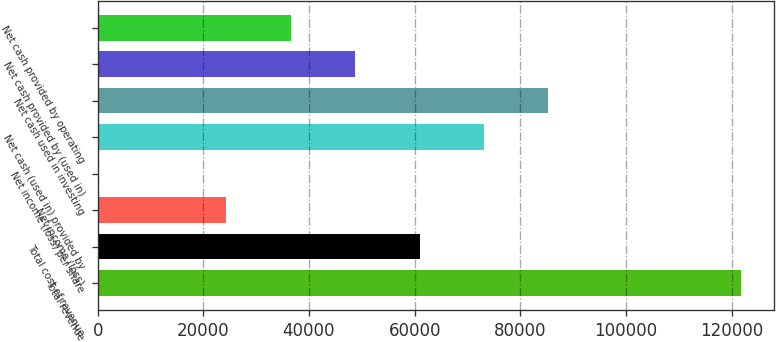<chart> <loc_0><loc_0><loc_500><loc_500><bar_chart><fcel>Total revenue<fcel>Total cost of revenue<fcel>Net income (loss)<fcel>Net income (loss) per share<fcel>Net cash (used in) provided by<fcel>Net cash used in investing<fcel>Net cash provided by (used in)<fcel>Net cash provided by operating<nl><fcel>121861<fcel>60930.6<fcel>24372.3<fcel>0.11<fcel>73116.6<fcel>85302.7<fcel>48744.5<fcel>36558.4<nl></chart> 